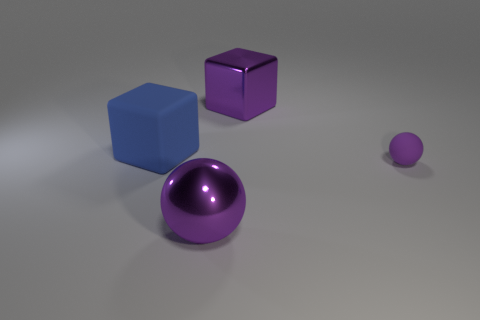Subtract 2 balls. How many balls are left? 0 Add 4 large purple metallic cubes. How many large purple metallic cubes exist? 5 Add 3 purple shiny cubes. How many objects exist? 7 Subtract 2 purple spheres. How many objects are left? 2 Subtract all purple blocks. Subtract all cyan cylinders. How many blocks are left? 1 Subtract all purple cylinders. How many blue cubes are left? 1 Subtract all large metallic cubes. Subtract all big purple things. How many objects are left? 1 Add 4 big blue rubber cubes. How many big blue rubber cubes are left? 5 